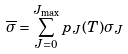<formula> <loc_0><loc_0><loc_500><loc_500>\overline { \sigma } = \sum _ { J = 0 } ^ { J _ { \max } } p _ { J } ( T ) \sigma _ { J }</formula> 